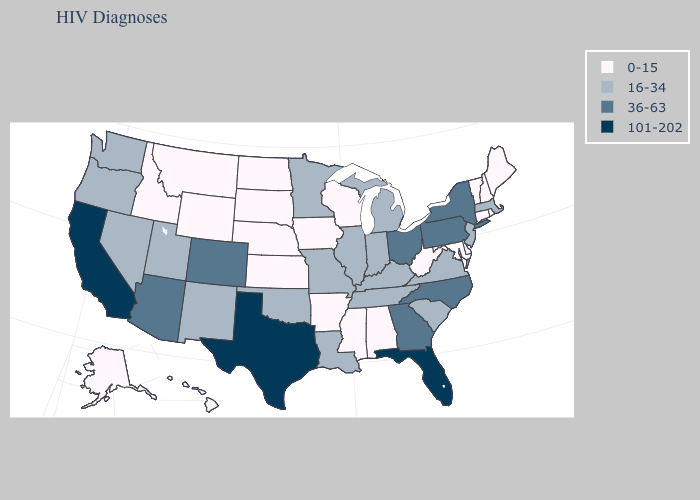What is the value of Vermont?
Keep it brief. 0-15. Does Montana have the lowest value in the West?
Give a very brief answer. Yes. What is the value of Montana?
Write a very short answer. 0-15. What is the value of Indiana?
Answer briefly. 16-34. What is the value of Washington?
Give a very brief answer. 16-34. Does the first symbol in the legend represent the smallest category?
Keep it brief. Yes. What is the highest value in states that border Delaware?
Write a very short answer. 36-63. Does Delaware have the highest value in the USA?
Short answer required. No. Does California have the highest value in the USA?
Answer briefly. Yes. What is the lowest value in the MidWest?
Be succinct. 0-15. Does Minnesota have a higher value than Texas?
Write a very short answer. No. Is the legend a continuous bar?
Quick response, please. No. Does the first symbol in the legend represent the smallest category?
Concise answer only. Yes. Which states have the lowest value in the USA?
Give a very brief answer. Alabama, Alaska, Arkansas, Connecticut, Delaware, Hawaii, Idaho, Iowa, Kansas, Maine, Maryland, Mississippi, Montana, Nebraska, New Hampshire, North Dakota, Rhode Island, South Dakota, Vermont, West Virginia, Wisconsin, Wyoming. Among the states that border Arkansas , which have the lowest value?
Quick response, please. Mississippi. 